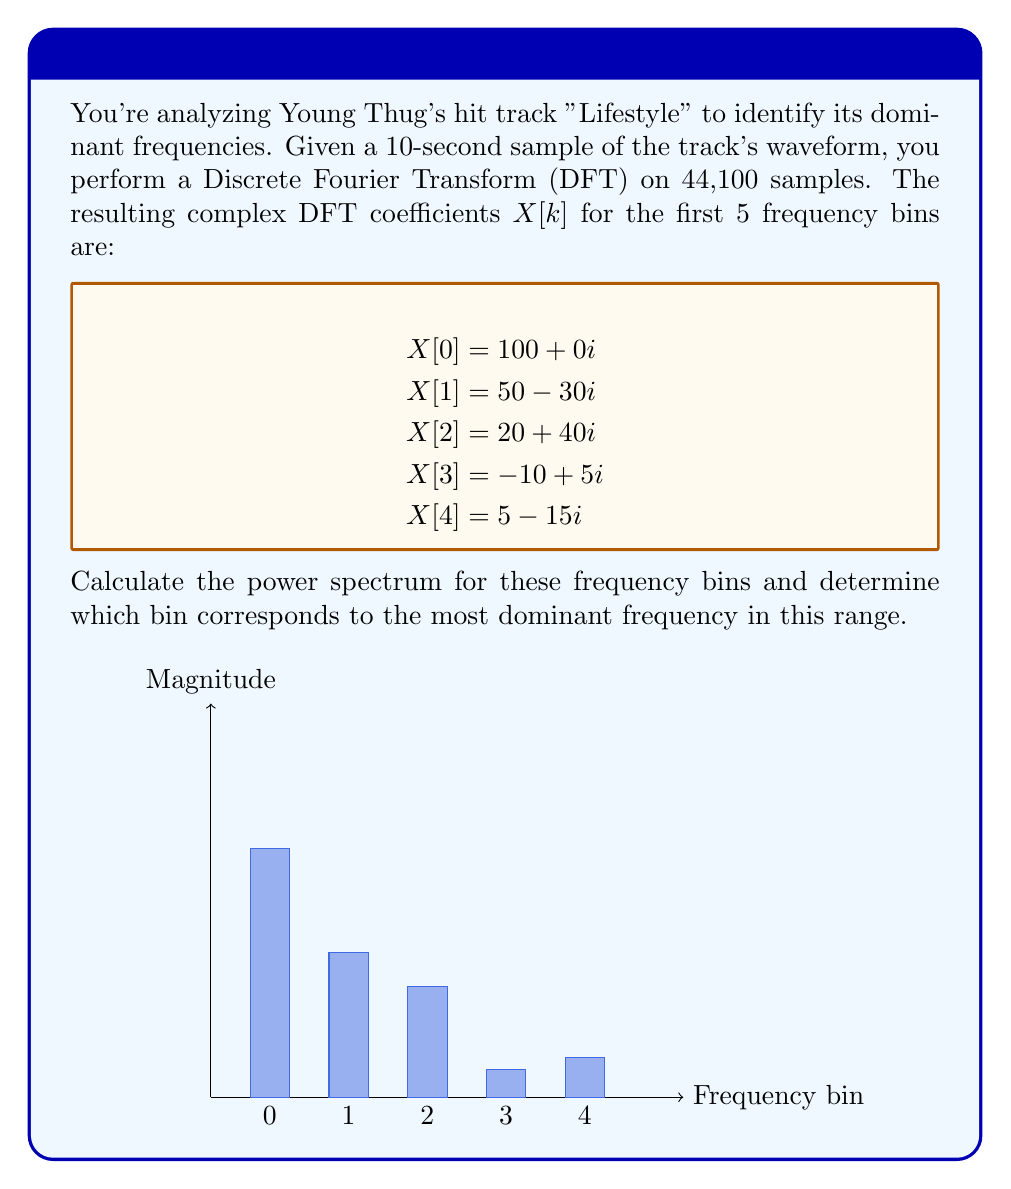Give your solution to this math problem. To solve this problem, we need to follow these steps:

1) The power spectrum is calculated as the squared magnitude of the DFT coefficients.

2) For a complex number $a + bi$, the magnitude is given by $\sqrt{a^2 + b^2}$.

3) Let's calculate the power for each bin:

   For $X[0]$: $P[0] = (100)^2 + (0)^2 = 10,000$
   
   For $X[1]$: $P[1] = (50)^2 + (-30)^2 = 3,400$
   
   For $X[2]$: $P[2] = (20)^2 + (40)^2 = 2,000$
   
   For $X[3]$: $P[3] = (-10)^2 + (5)^2 = 125$
   
   For $X[4]$: $P[4] = (5)^2 + (-15)^2 = 250$

4) The most dominant frequency corresponds to the bin with the highest power.

5) Comparing the power values, we can see that $P[0]$ has the highest value at 10,000.

Therefore, the most dominant frequency in this range corresponds to bin 0.
Answer: Bin 0 (10,000) 